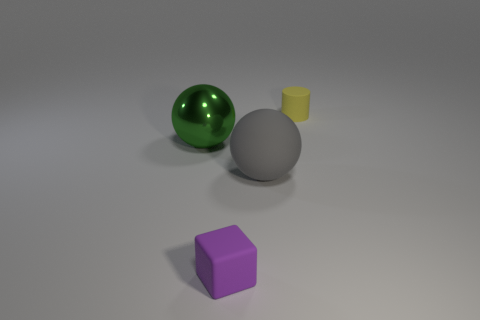Add 1 brown things. How many objects exist? 5 Subtract all cylinders. How many objects are left? 3 Subtract all big gray spheres. Subtract all gray metal things. How many objects are left? 3 Add 3 rubber things. How many rubber things are left? 6 Add 4 small yellow matte cylinders. How many small yellow matte cylinders exist? 5 Subtract 0 cyan cubes. How many objects are left? 4 